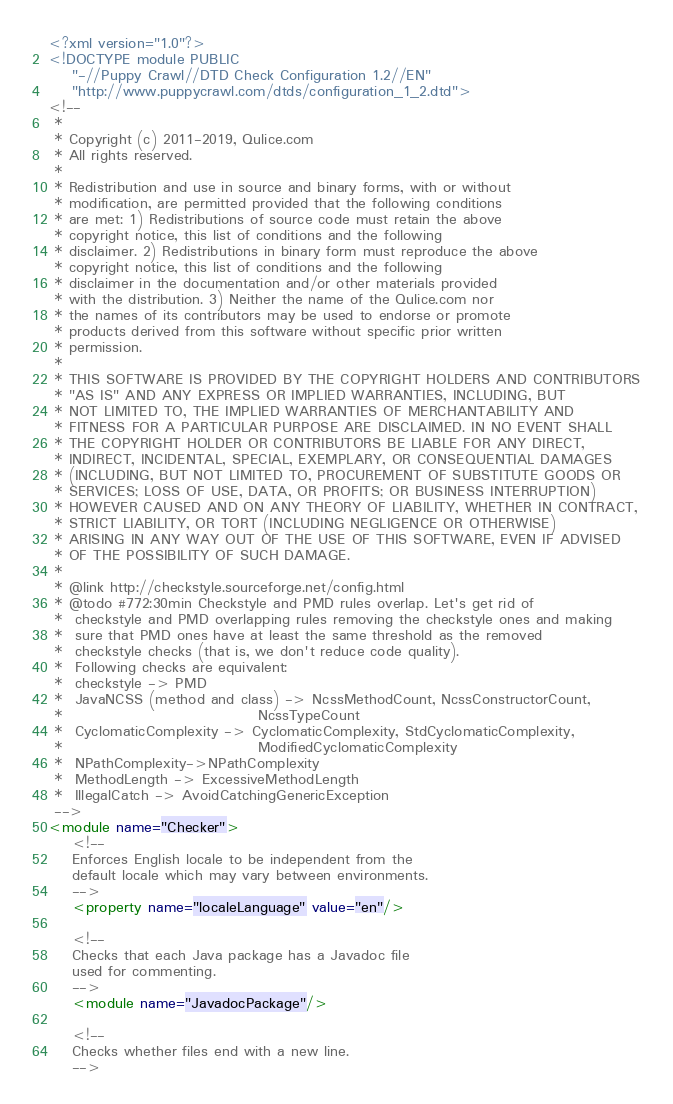Convert code to text. <code><loc_0><loc_0><loc_500><loc_500><_XML_><?xml version="1.0"?>
<!DOCTYPE module PUBLIC
    "-//Puppy Crawl//DTD Check Configuration 1.2//EN"
    "http://www.puppycrawl.com/dtds/configuration_1_2.dtd">
<!--
 *
 * Copyright (c) 2011-2019, Qulice.com
 * All rights reserved.
 *
 * Redistribution and use in source and binary forms, with or without
 * modification, are permitted provided that the following conditions
 * are met: 1) Redistributions of source code must retain the above
 * copyright notice, this list of conditions and the following
 * disclaimer. 2) Redistributions in binary form must reproduce the above
 * copyright notice, this list of conditions and the following
 * disclaimer in the documentation and/or other materials provided
 * with the distribution. 3) Neither the name of the Qulice.com nor
 * the names of its contributors may be used to endorse or promote
 * products derived from this software without specific prior written
 * permission.
 *
 * THIS SOFTWARE IS PROVIDED BY THE COPYRIGHT HOLDERS AND CONTRIBUTORS
 * "AS IS" AND ANY EXPRESS OR IMPLIED WARRANTIES, INCLUDING, BUT
 * NOT LIMITED TO, THE IMPLIED WARRANTIES OF MERCHANTABILITY AND
 * FITNESS FOR A PARTICULAR PURPOSE ARE DISCLAIMED. IN NO EVENT SHALL
 * THE COPYRIGHT HOLDER OR CONTRIBUTORS BE LIABLE FOR ANY DIRECT,
 * INDIRECT, INCIDENTAL, SPECIAL, EXEMPLARY, OR CONSEQUENTIAL DAMAGES
 * (INCLUDING, BUT NOT LIMITED TO, PROCUREMENT OF SUBSTITUTE GOODS OR
 * SERVICES; LOSS OF USE, DATA, OR PROFITS; OR BUSINESS INTERRUPTION)
 * HOWEVER CAUSED AND ON ANY THEORY OF LIABILITY, WHETHER IN CONTRACT,
 * STRICT LIABILITY, OR TORT (INCLUDING NEGLIGENCE OR OTHERWISE)
 * ARISING IN ANY WAY OUT OF THE USE OF THIS SOFTWARE, EVEN IF ADVISED
 * OF THE POSSIBILITY OF SUCH DAMAGE.
 *
 * @link http://checkstyle.sourceforge.net/config.html
 * @todo #772:30min Checkstyle and PMD rules overlap. Let's get rid of
 *  checkstyle and PMD overlapping rules removing the checkstyle ones and making
 *  sure that PMD ones have at least the same threshold as the removed
 *  checkstyle checks (that is, we don't reduce code quality).
 *  Following checks are equivalent:
 *  checkstyle -> PMD
 *  JavaNCSS (method and class) -> NcssMethodCount, NcssConstructorCount,
 *                                 NcssTypeCount
 *  CyclomaticComplexity -> CyclomaticComplexity, StdCyclomaticComplexity,
 *                                 ModifiedCyclomaticComplexity
 *  NPathComplexity->NPathComplexity
 *  MethodLength -> ExcessiveMethodLength
 *  IllegalCatch -> AvoidCatchingGenericException
 -->
<module name="Checker">
    <!--
    Enforces English locale to be independent from the
    default locale which may vary between environments.
    -->
    <property name="localeLanguage" value="en"/>

    <!--
    Checks that each Java package has a Javadoc file
    used for commenting.
    -->
    <module name="JavadocPackage"/>

    <!--
    Checks whether files end with a new line.
    --></code> 